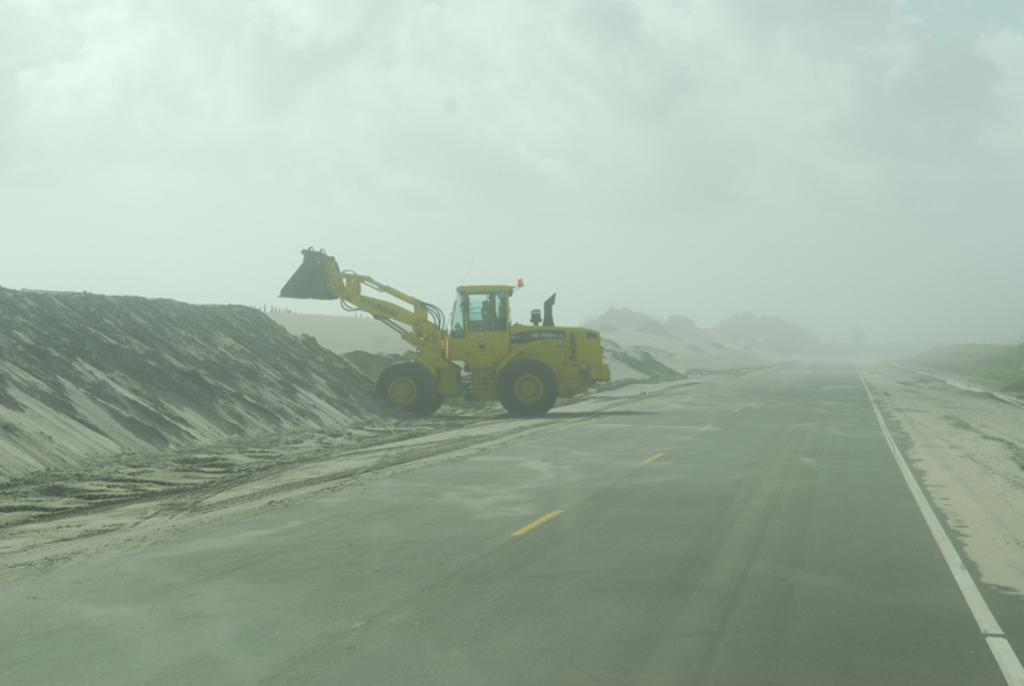What type of machinery is present on the road in the image? There is an excavator on the road in the image. What is in front of the excavator? There is sand in front of the excavator. What can be seen in the background of the image? The sky is visible in the background of the image. What type of plough is being used to scale the mountain in the image? There is no plough or mountain present in the image. The image features an excavator on a road with sand in front of it, and the sky visible in the background. 